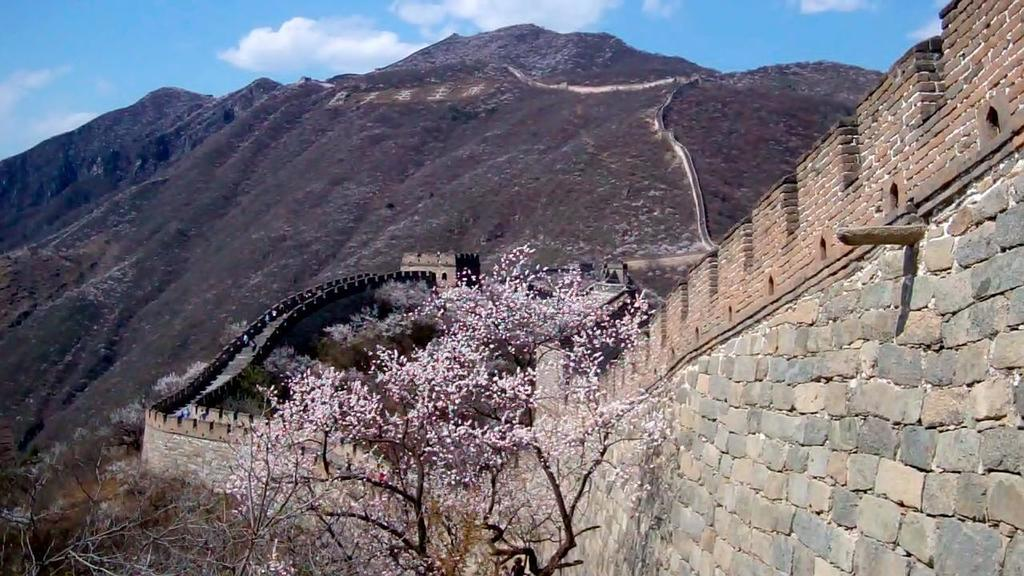What famous landmark is visible in the image? The Great Wall of China is visible in the image. What type of vegetation can be seen in the image? There are flowers and trees in the image. What type of terrain is present in the image? There are hills in the image. What is visible in the background of the image? The sky is visible in the background of the image. How many minutes does it take for the flowers to blink their eyes in the image? There are no flowers blinking their eyes in the image, as flowers do not have eyes. 